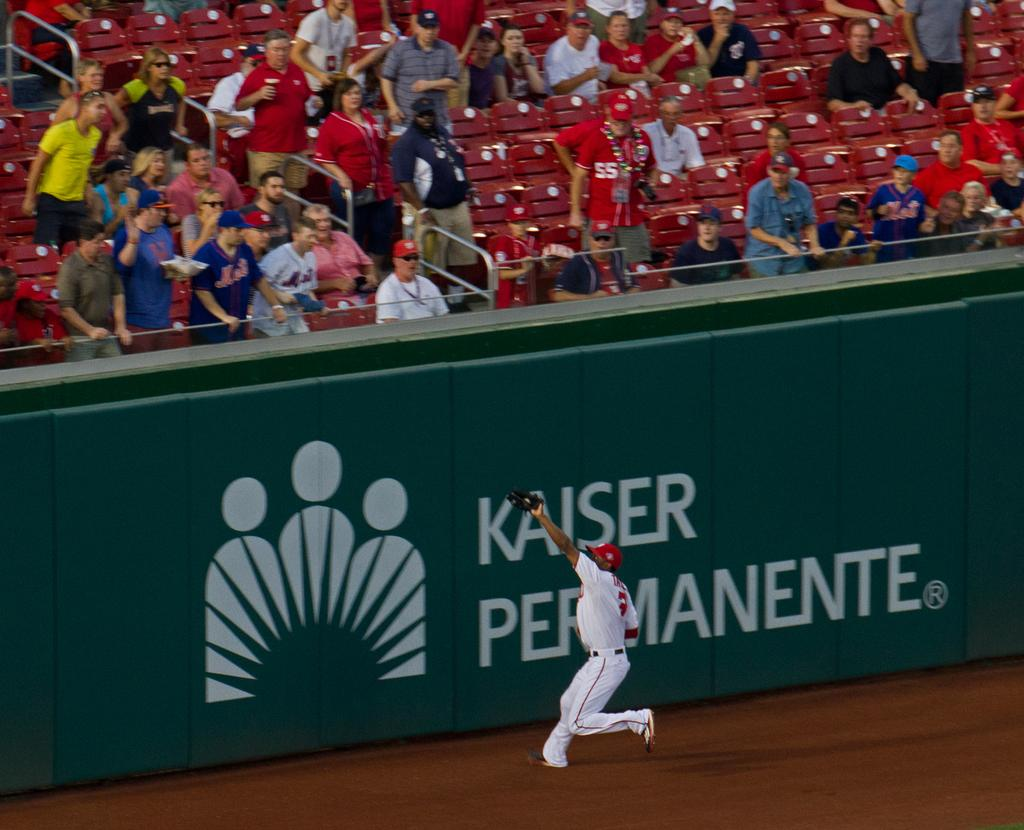<image>
Relay a brief, clear account of the picture shown. A baseball outfielder field a fly ball just in front of the Kaiser Permanente portion of the fence 